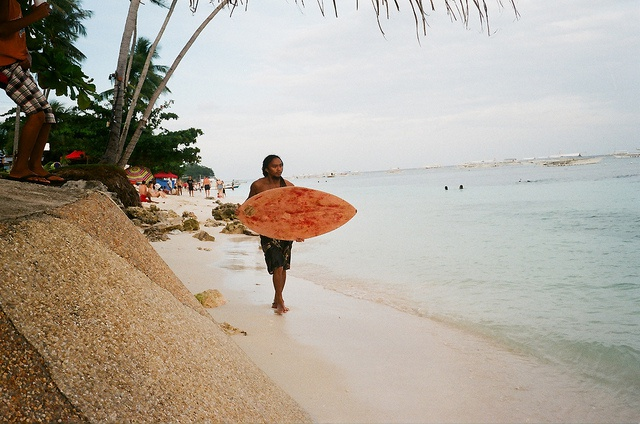Describe the objects in this image and their specific colors. I can see people in black, maroon, and gray tones, surfboard in black, red, brown, and salmon tones, people in black, maroon, and brown tones, umbrella in black, olive, brown, and maroon tones, and people in black, salmon, maroon, and brown tones in this image. 